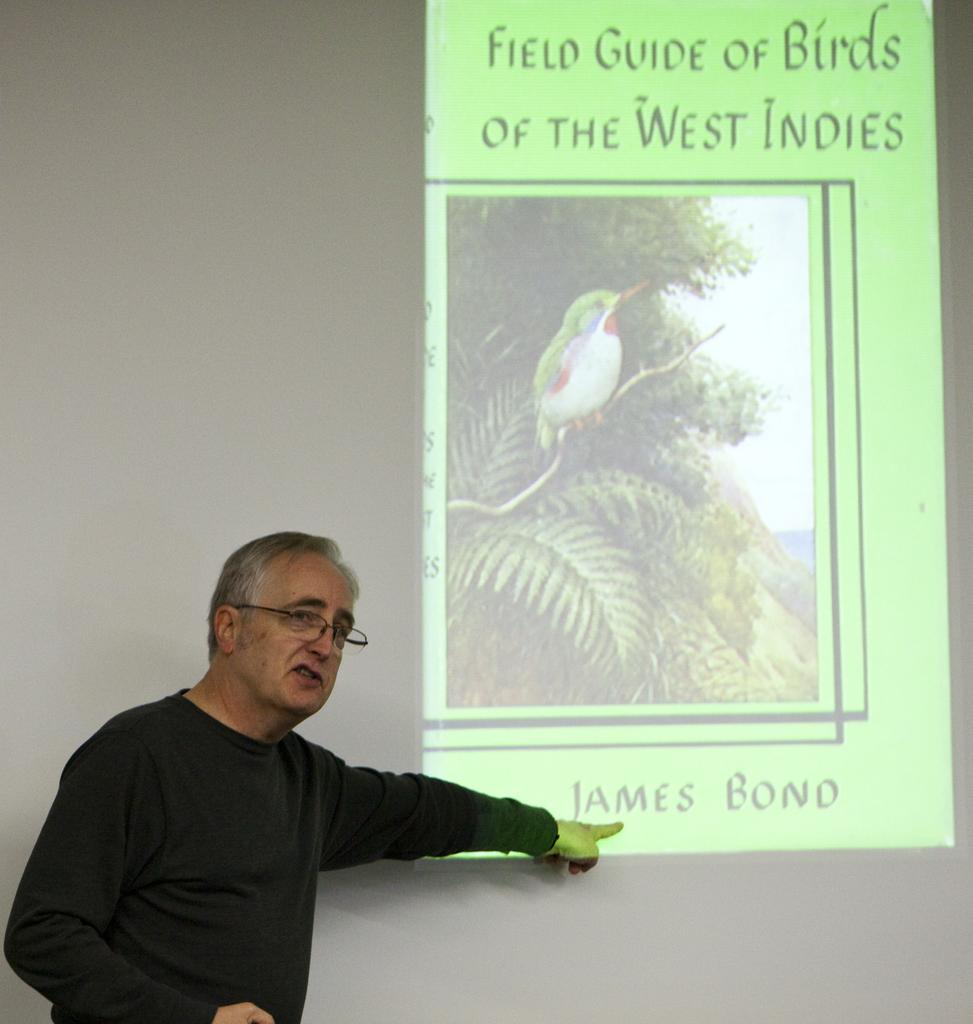What can be seen in the image? There is a person standing in the image. Can you describe the person's appearance? The person is wearing spectacles. What is on the wall in the image? There is a screen on the wall in the image. What is displayed on the screen? The screen displays images and text. How does the wind affect the images and text on the screen in the image? There is no wind present in the image, so it cannot affect the screen or its contents. 